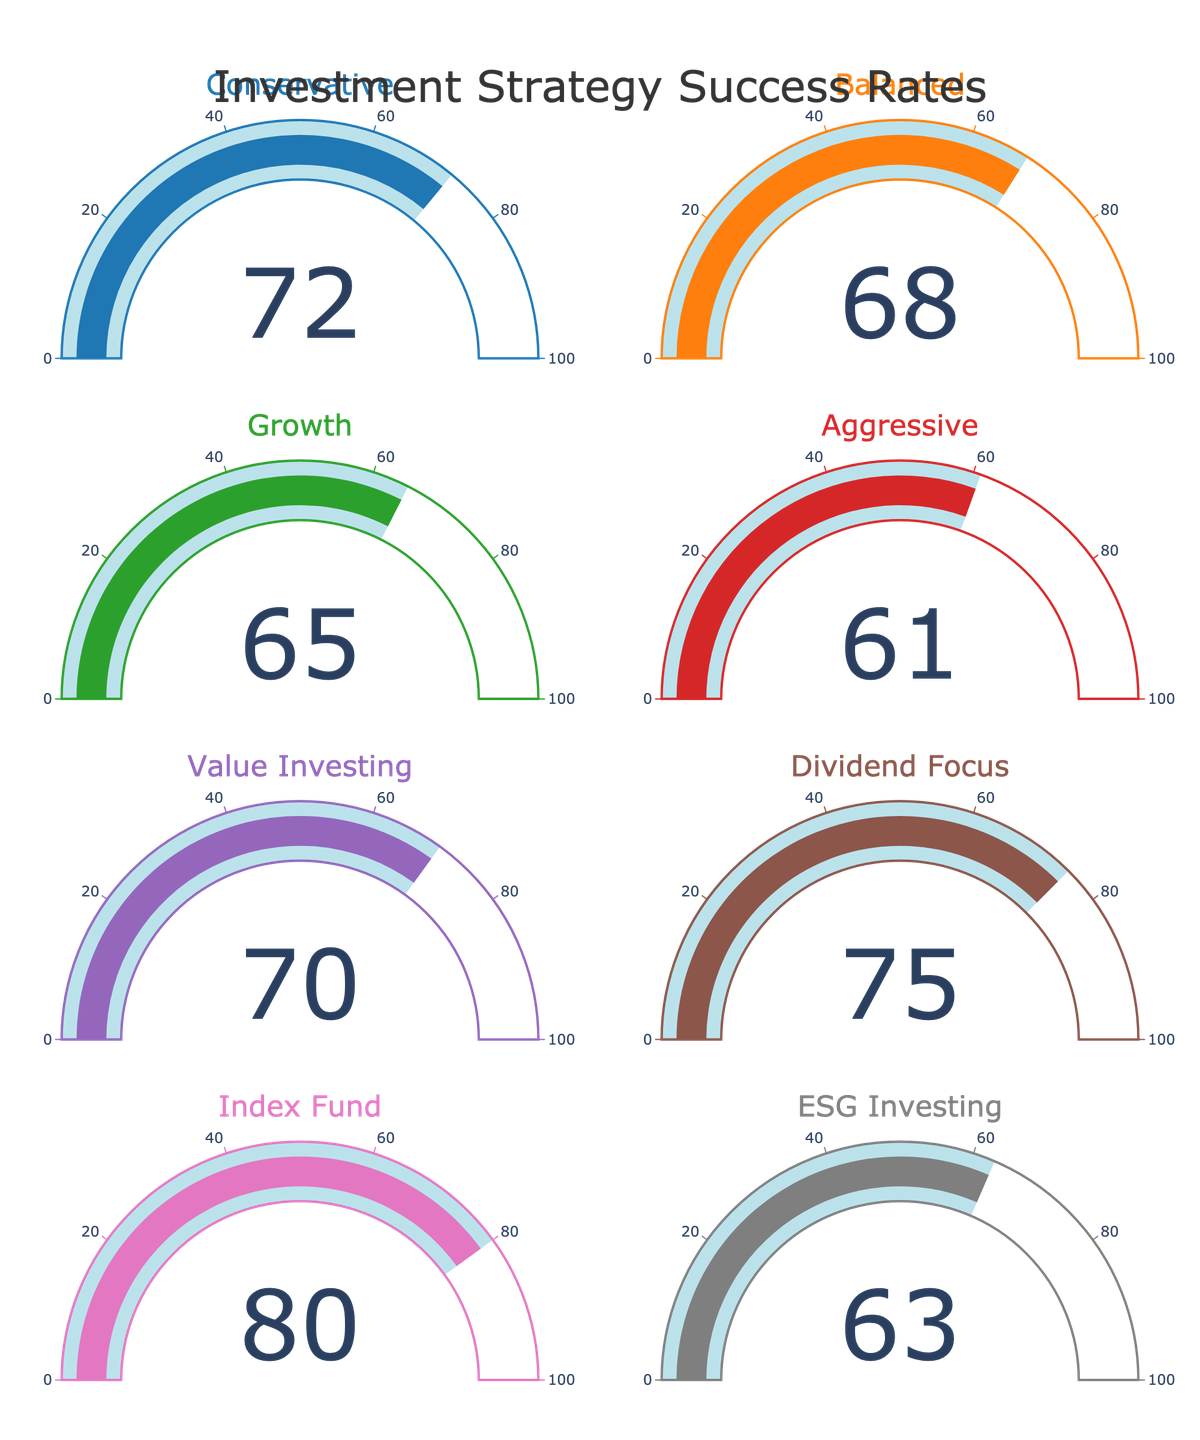What is the success rate of the Conservative strategy? The gauge for the Conservative strategy shows a number. This number represents the success rate.
Answer: 72 Which investment strategy has the highest success rate? By examining each gauge, the highest value can be identified. The Index Fund strategy has the highest success rate of 80.
Answer: Index Fund What is the difference in success rate between Dividend Focus and Aggressive strategies? Locate the success rates of both Dividend Focus (75) and Aggressive (61) strategies. Subtract the success rate of Aggressive from Dividend Focus. 75 - 61 = 14.
Answer: 14 How many strategies have a success rate above 70? Count the number of gauges with a value greater than 70. There are three such strategies: Conservative (72), Dividend Focus (75), and Index Fund (80).
Answer: 3 What is the average success rate of all the investment strategies? Sum all the success rates: 72 + 68 + 65 + 61 + 70 + 75 + 80 + 63 = 554. Divide by the number of strategies: 554 / 8 = 69.25.
Answer: 69.25 Compare the success rates of ESG Investing and Balanced strategies. Which one is higher and by how much? Identify the success rates: ESG Investing (63) and Balanced (68). Subtract the ESG Investing from Balanced: 68 - 63 = 5. Balanced is higher by 5.
Answer: Balanced is higher by 5 What is the total success rate for the Conservative, Growth, and Value Investing strategies? Add the success rates of these strategies: Conservative (72), Growth (65), and Value Investing (70). 72 + 65 + 70 = 207.
Answer: 207 Which strategy has the lowest success rate, and what is it? Identify the strategy with the smallest number on its gauge, which is the Aggressive strategy with a success rate of 61.
Answer: Aggressive, 61 What is the range of success rates across all investment strategies? Subtract the lowest success rate from the highest: 80 (Index Fund) - 61 (Aggressive) = 19.
Answer: 19 Compare the success rate of Value Investing to the overall average success rate. Is Value Investing above or below the average? The average success rate is 69.25, and the Value Investing success rate is 70. Since 70 is greater than 69.25, Value Investing is above the average.
Answer: Above the average 